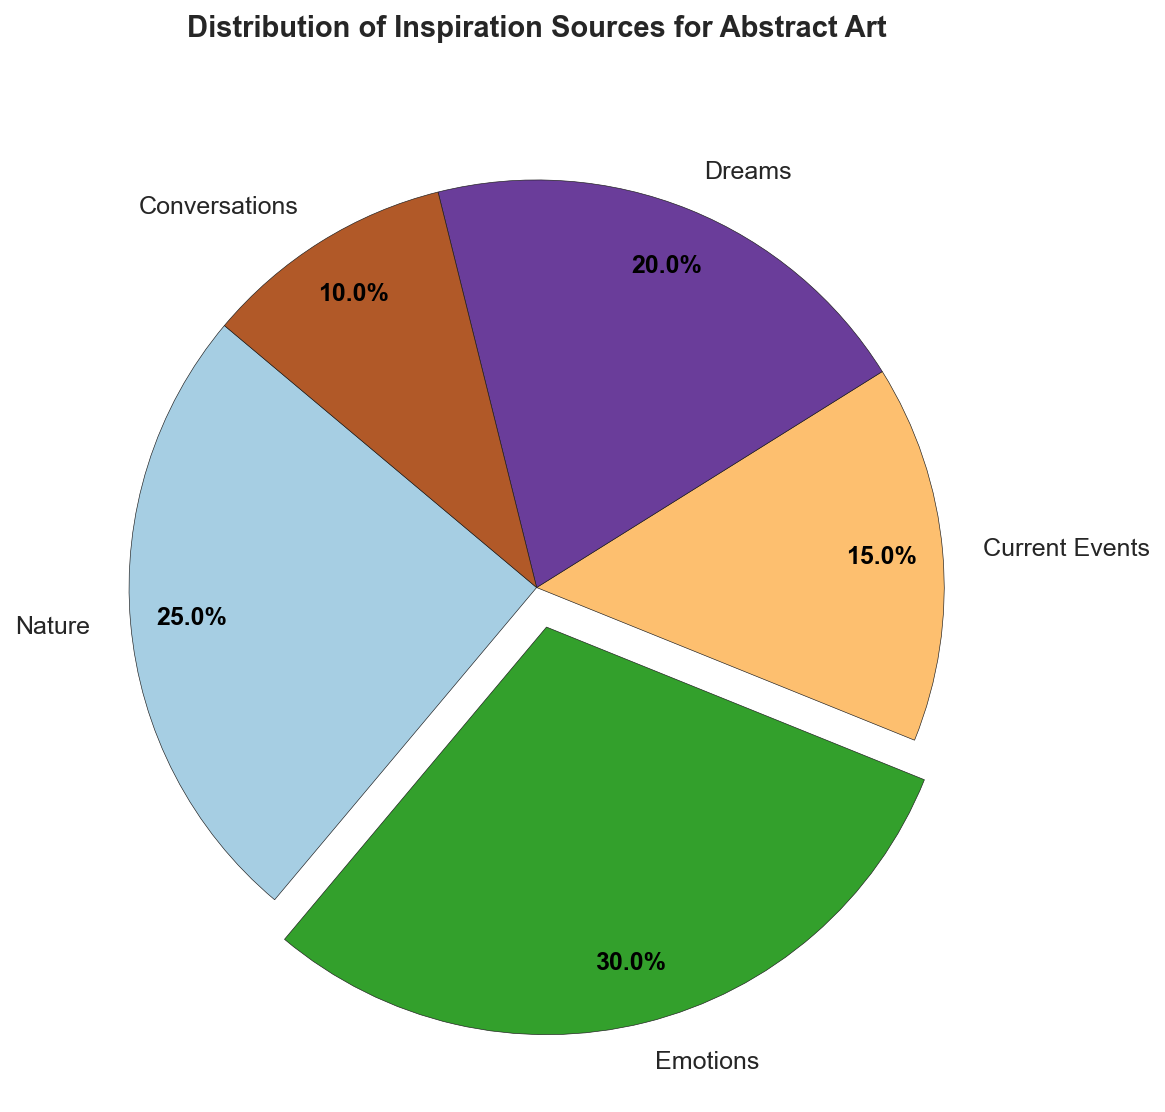What is the most common inspiration source for abstract art based on the chart? The most common inspiration source can be identified by the largest section of the pie chart, which is labeled "Emotions" with 30%
Answer: Emotions Which sources of inspiration combined account for half of the inspirations? Combine sources to reach 50%. "Emotions" (30%) plus "Nature" (25%) together total 55%, which exceeds 50%
Answer: Emotions and Nature Is the percentage of inspiration from "Current Events" greater or less than from "Dreams"? Compare the sections of the pie chart labeled "Current Events" (15%) and "Dreams" (20%). "Current Events" is less than "Dreams"
Answer: Less What is the color of the section representing "Nature"? Identify the color used in the section labeled "Nature". It corresponds to the first section's color from the colormap
Answer: Blue (or color from colormap) By how many percentage points is inspiration from "Emotions" higher than from "Conversations"? Subtract the percentage of "Conversations" (10%) from "Emotions" (30%), i.e., 30% - 10% = 20%
Answer: 20% If "Dreams" and "Conversations" were combined into a single category, what percentage would they represent together? Add the percentages for "Dreams" (20%) and "Conversations" (10%), i.e., 20% + 10% = 30%
Answer: 30% Which source is least common for abstract art inspiration? Identify the smallest section of the pie chart, which is labeled "Conversations" with 10%
Answer: Conversations Is "Nature" or "Dreams" a more common inspiration source? Compare the sections labeled "Nature" (25%) and "Dreams" (20%). "Nature" is greater than "Dreams"
Answer: Nature If the percentages of "Nature" and "Current Events" were summed, would they exceed the percentage of "Emotions"? Add the percentages: "Nature" (25%) + "Current Events" (15%) = 40%. Compare with "Emotions" (30%). 40% > 30%
Answer: Yes What percentage of inspiration sources are not related to "Emotions" or "Nature"? Calculate the total percentage and subtract "Emotions" (30%) and "Nature" (25%), i.e., 100% - 55% = 45%
Answer: 45% 